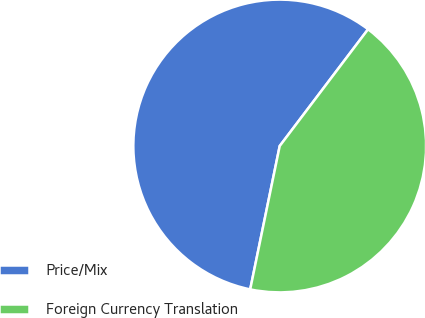<chart> <loc_0><loc_0><loc_500><loc_500><pie_chart><fcel>Price/Mix<fcel>Foreign Currency Translation<nl><fcel>57.08%<fcel>42.92%<nl></chart> 